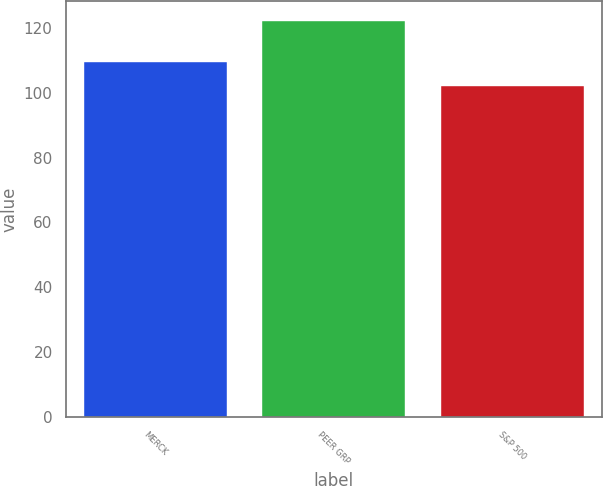<chart> <loc_0><loc_0><loc_500><loc_500><bar_chart><fcel>MERCK<fcel>PEER GRP<fcel>S&P 500<nl><fcel>109.4<fcel>122.23<fcel>102.1<nl></chart> 